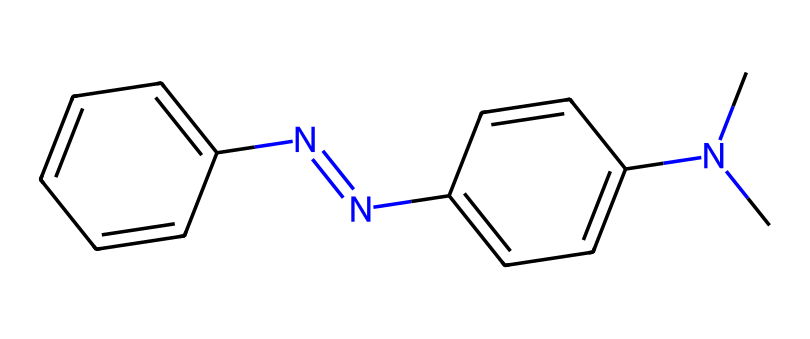What is the molecular formula of this compound? By analyzing the SMILES representation, we can count the atoms present. The structure contains 12 carbon atoms, 14 hydrogen atoms, 2 nitrogen atoms, resulting in the formula C12H14N2.
Answer: C12H14N2 How many carbon atoms are there in this dye? From the SMILES string, we can identify the number of carbon atoms by counting the 'c' or 'C' characters. In this case, there are 12 carbon atoms.
Answer: 12 What type of bond connects the two aromatic rings in this compound? The SMILES indicates the presence of a 'N=N' bond, which specifies a double bond between the nitrogen atoms that link the two aromatic rings.
Answer: double bond Which type of geometric isomers can azobenzene exhibit? The compound features a central double bond (N=N), allowing it to have cis and trans geometric isomers based on the arrangement around this double bond.
Answer: cis and trans What functional groups are present in this dye? The SMILES shows the presence of two dimethylamino groups (N(C)C), indicating the presence of amine functional groups in the structure.
Answer: amine Does this compound contain any symmetry elements? Upon evaluation, the compound has reflective symmetry due to its arrangement around the central N=N double bond, leading to the presence of symmetry elements.
Answer: yes How many distinct geometric isomers could be formed for this compound? Given that there are two different substituents on each nitrogen (the dimethyl group and the phenyl groups), there can be two distinct geometric isomers: cis and trans.
Answer: 2 